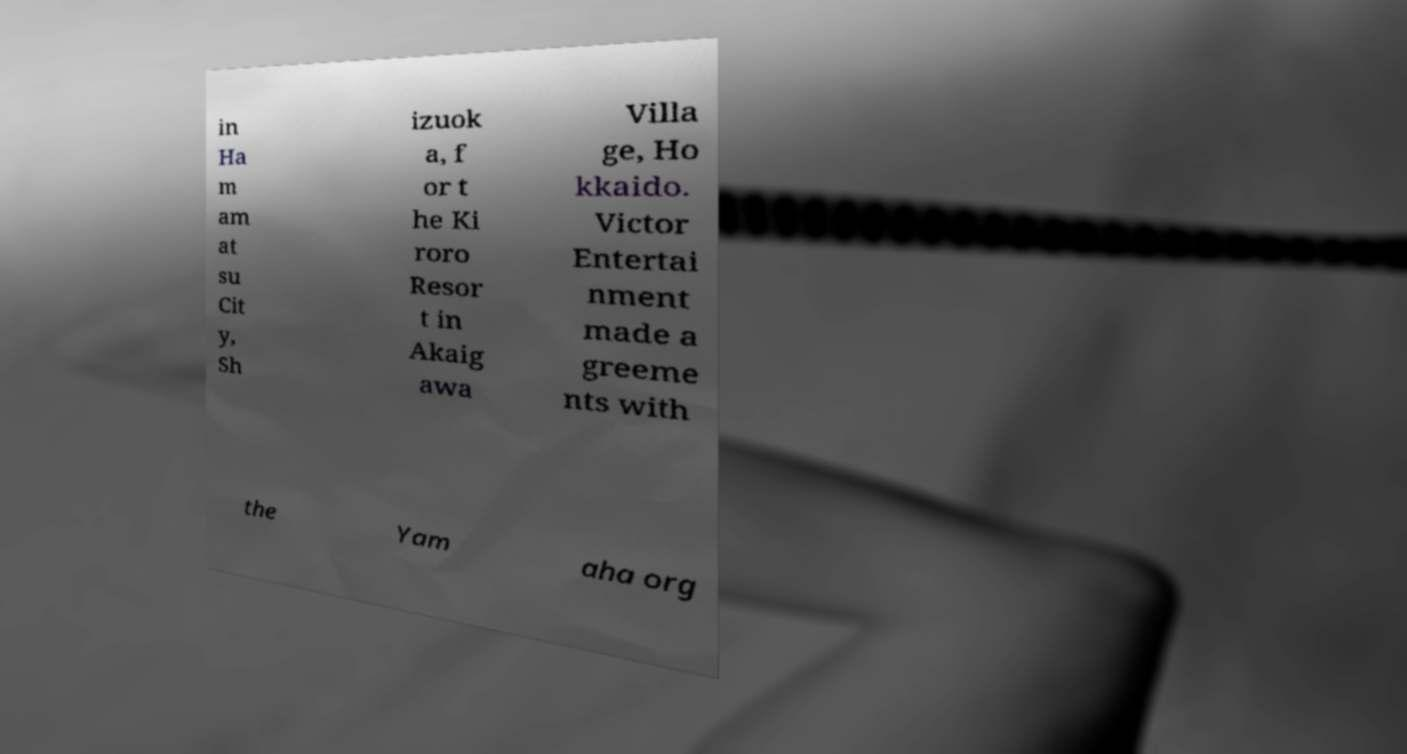Could you assist in decoding the text presented in this image and type it out clearly? in Ha m am at su Cit y, Sh izuok a, f or t he Ki roro Resor t in Akaig awa Villa ge, Ho kkaido. Victor Entertai nment made a greeme nts with the Yam aha org 